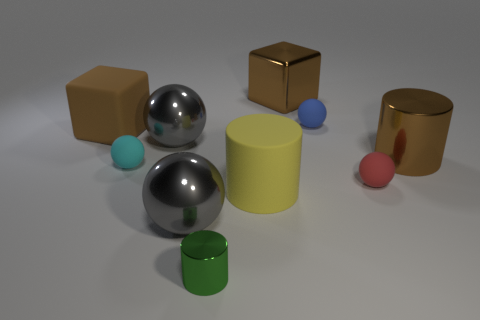Are there any yellow rubber cylinders that have the same size as the cyan thing?
Give a very brief answer. No. The large shiny object that is the same color as the large metallic cube is what shape?
Keep it short and to the point. Cylinder. What number of gray shiny things are the same size as the brown cylinder?
Your answer should be compact. 2. There is a brown block behind the brown matte object; does it have the same size as the matte sphere that is on the left side of the small green cylinder?
Your answer should be compact. No. What number of objects are either large rubber cylinders or small cyan rubber balls that are left of the tiny green cylinder?
Make the answer very short. 2. What is the color of the matte block?
Your answer should be very brief. Brown. There is a cylinder to the right of the big cube that is behind the large rubber thing left of the big rubber cylinder; what is it made of?
Keep it short and to the point. Metal. There is a brown object that is made of the same material as the cyan thing; what is its size?
Give a very brief answer. Large. Are there any metal things that have the same color as the big metallic cylinder?
Make the answer very short. Yes. Is the size of the yellow thing the same as the metallic cylinder in front of the large shiny cylinder?
Offer a very short reply. No. 